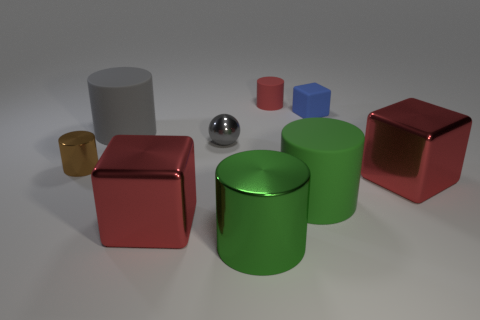Subtract all small metallic cylinders. How many cylinders are left? 4 Subtract all green cylinders. How many cylinders are left? 3 Subtract 1 cylinders. How many cylinders are left? 4 Subtract all gray spheres. How many blue cubes are left? 1 Add 6 large cyan matte blocks. How many large cyan matte blocks exist? 6 Subtract 1 gray balls. How many objects are left? 8 Subtract all cylinders. How many objects are left? 4 Subtract all cyan cubes. Subtract all purple cylinders. How many cubes are left? 3 Subtract all balls. Subtract all matte things. How many objects are left? 4 Add 8 brown objects. How many brown objects are left? 9 